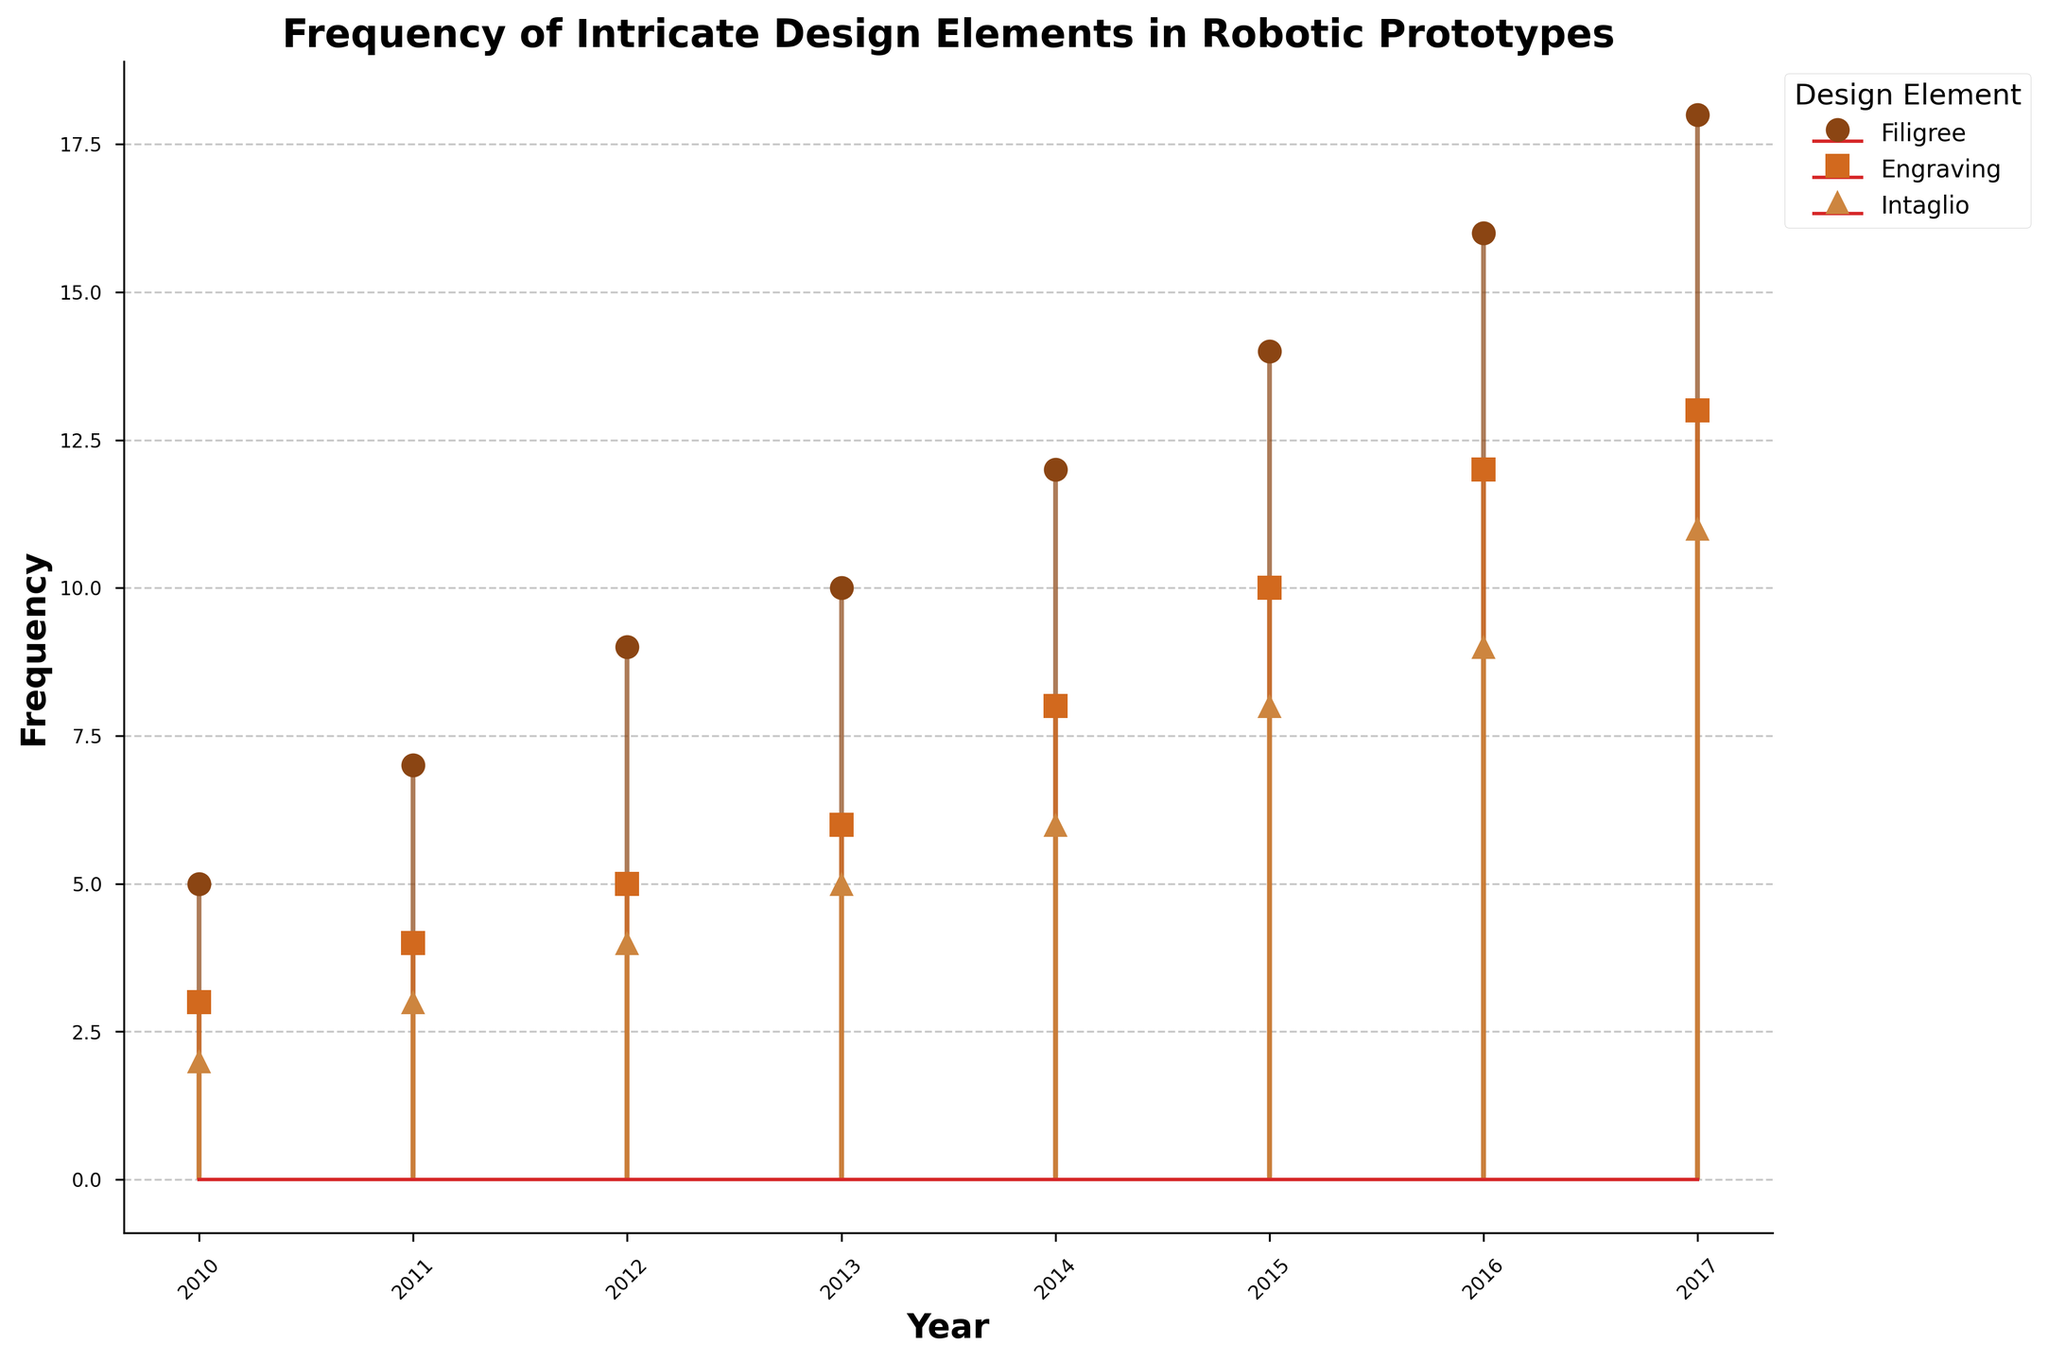What is the title of the plot? The title of the plot is shown in bold at the top of the figure. It reads "Frequency of Intricate Design Elements in Robotic Prototypes."
Answer: Frequency of Intricate Design Elements in Robotic Prototypes What are the design elements shown in the legend? The legend, located at the upper left and labeled "Design Element," lists the distinct design elements being tracked. These are "Filigree," "Engraving," and "Intaglio."
Answer: Filigree, Engraving, Intaglio Which year had the highest frequency for 'Intaglio'? By observing the stem plot line for 'Intaglio', which is marked with a specific marker and color, you can see that the highest stem appears in the year 2017.
Answer: 2017 What is the total frequency of 'Filigree' from 2010 to 2017? To find the total frequency, sum up the 'Filigree' frequencies for each year from the plot: 5 + 7 + 9 + 10 + 12 + 14 + 16 + 18. After adding these values, the total frequency is 91.
Answer: 91 Which design element had the lowest frequency in 2014? By comparing the heights of the stems for each design element in 2014, you will see that 'Intaglio' has the lowest frequency.
Answer: Intaglio Between which two consecutive years did the frequency of 'Engraving' increase the most? To determine this, compare the increments in 'Engraving' frequencies between consecutive years. The largest increase is between 2014 (8) and 2015 (10), which is an increase of 2.
Answer: 2014 to 2015 How does the frequency of 'Filigree' in 2016 compare to its frequency in 2010? By observing the stem heights for 'Filigree' in both years, the frequency in 2016 is 16, while it is 5 in 2010. Thus, the frequency is higher in 2016 compared to 2010.
Answer: Higher in 2016 By how much did the frequency of 'Intaglio' change from 2010 to 2017? The frequency in 2010 is 2, and in 2017 it is 11. The change in frequency is calculated as 11 - 2, resulting in an increase of 9.
Answer: Increased by 9 What is the mean frequency of 'Engraving' from 2010 to 2013? To find the mean, add the 'Engraving' frequencies for these years: 3 + 4 + 5 + 6, which gives a total of 18. The mean is then 18 divided by 4 (the number of years), which equals 4.5.
Answer: 4.5 